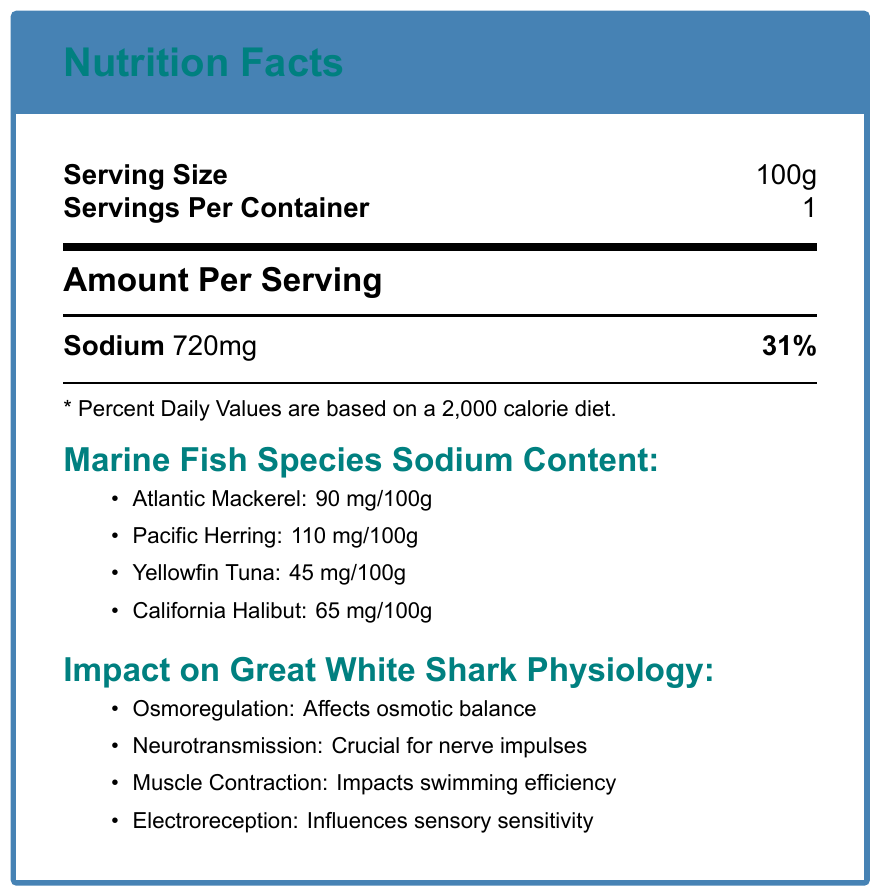what is the serving size mentioned in the document? The serving size is explicitly stated in the document as "Serving Size: 100g."
Answer: 100g how much sodium does a serving contain? According to the document, the "Amount Per Serving" for Sodium is 720 mg.
Answer: 720 mg what is the percentage of daily value for sodium in each serving? The document states that 720 mg of Sodium per serving corresponds to 31% of the daily value.
Answer: 31% list the sodium content of Yellowfin Tuna per 100g. The sodium content for Yellowfin Tuna is listed as 45 mg/100g in the document.
Answer: 45 mg which fish species mentioned has the highest sodium content per 100g? According to the document, Pacific Herring has the highest sodium content of 110 mg/100g.
Answer: Pacific Herring which of the following factors is said to influence the shark's sodium intake through diet?
A. Ocean Salinity
B. Water Temperature
C. Prey Availability The document lists "Prey Availability" as an environmental factor that influences the shark's sodium intake through diet.
Answer: C which of these research methods helps determine the shark's diet composition?
i. Satellite Tagging
ii. Stable Isotope Analysis
iii. Blood Chemistry Analysis The document mentions that "Stable Isotope Analysis" is used to determine the shark's diet composition.
Answer: ii. Stable Isotope Analysis does sodium play a role in great white shark muscle contractions? The document states that sodium ions play a role in muscle contractions, impacting swimming efficiency.
Answer: Yes summarize the main idea of the document. The document provides comprehensive information on sodium levels in marine fish and their physiological impact on great white sharks, including specific research methods and environmental influences.
Answer: The document details the sodium content in various marine fish species and explains the impacts of sodium levels on great white shark physiology, including aspects such as osmoregulation, neurotransmission, muscle contraction, and electroreception. It also highlights research methods and environmental factors affecting sharks. are the blood chemistry analysis and ocean salinity directly related to sodium levels in sharks? The document mentions blood chemistry analysis and ocean salinity as separate items but does not provide enough context to ascertain their direct relationship or interaction concerning sodium levels in sharks.
Answer: Not enough information 